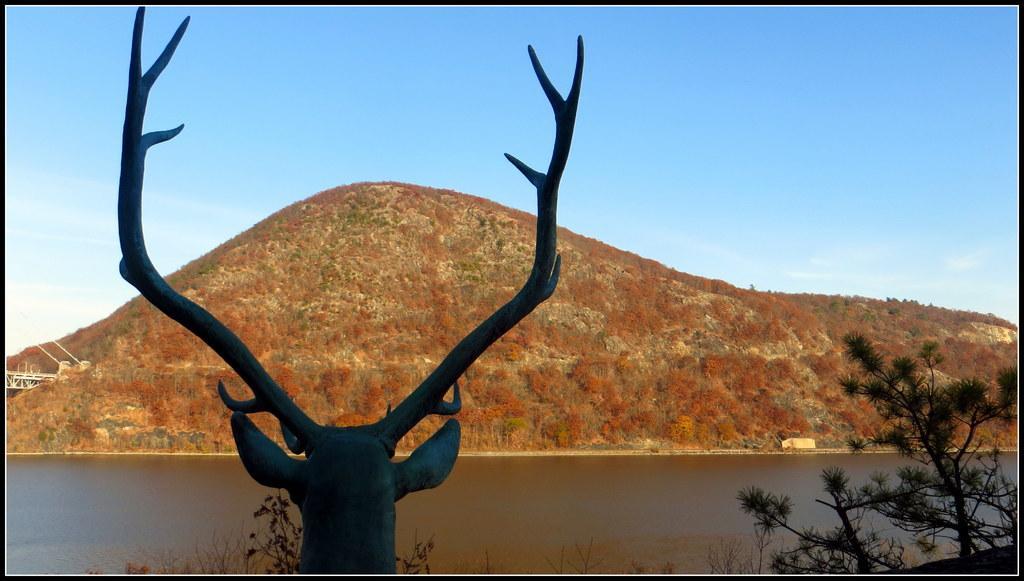In one or two sentences, can you explain what this image depicts? In this image we can see animal head with horns. In the back there is water. Also there are branches of trees. In the back there is hill. Also there is sky with clouds. 